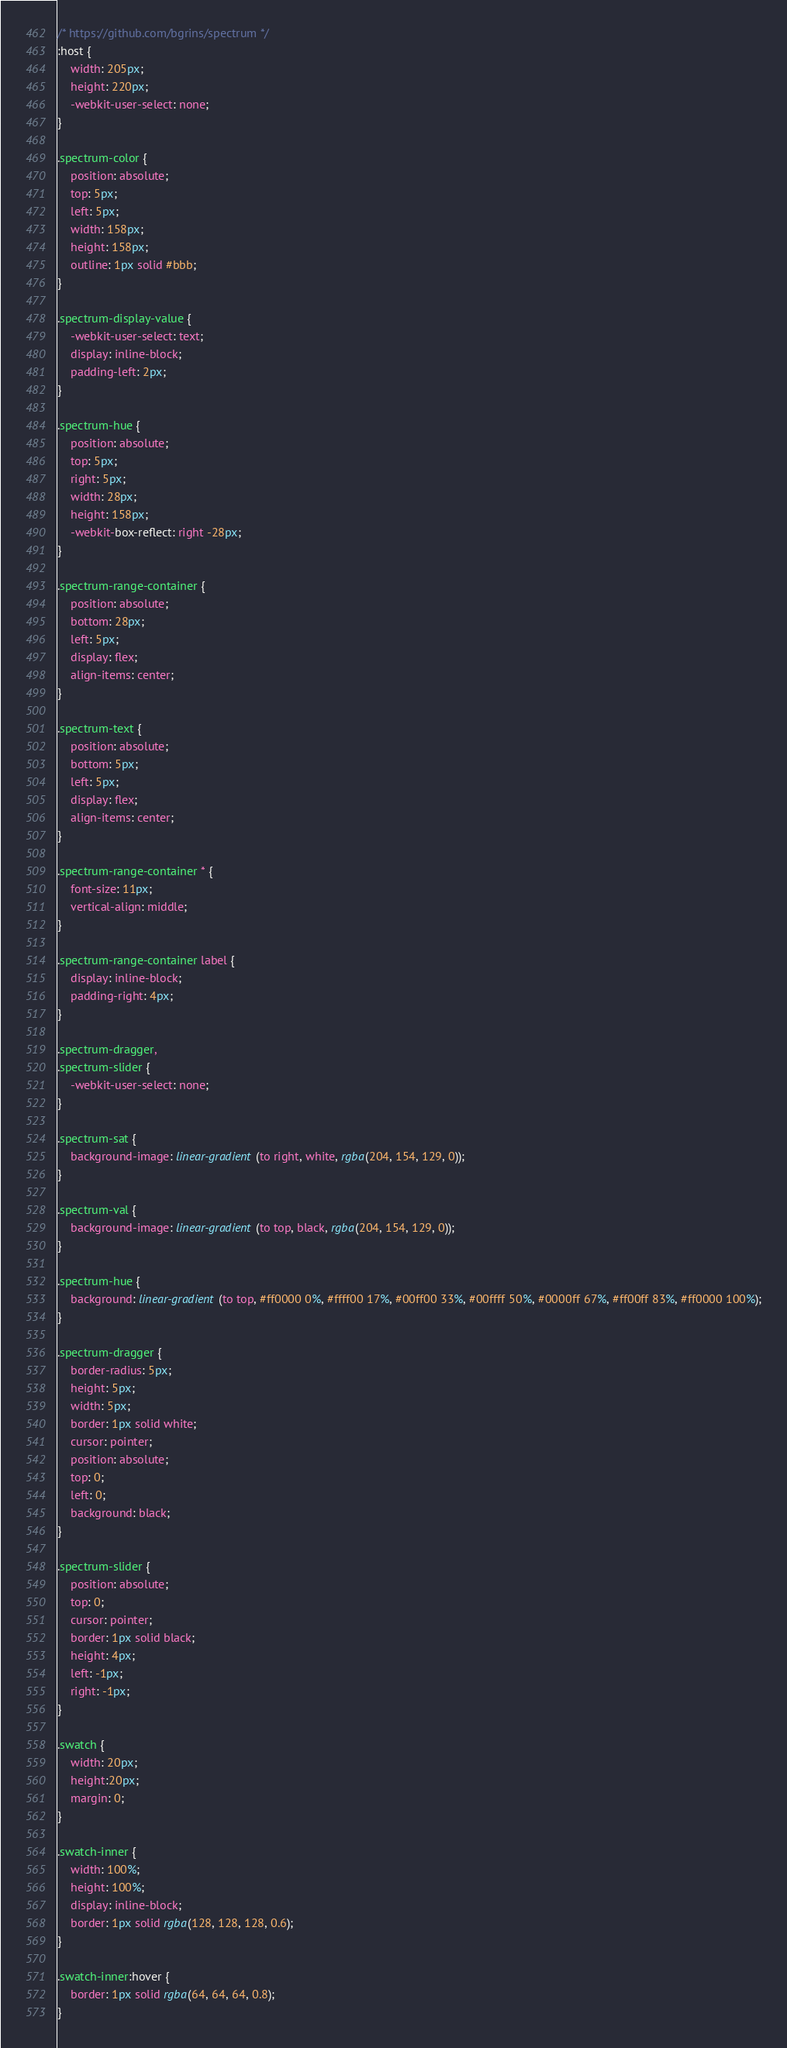<code> <loc_0><loc_0><loc_500><loc_500><_CSS_>/* https://github.com/bgrins/spectrum */
:host {
    width: 205px;
    height: 220px;
    -webkit-user-select: none;
}

.spectrum-color {
    position: absolute;
    top: 5px;
    left: 5px;
    width: 158px;
    height: 158px;
    outline: 1px solid #bbb;
}

.spectrum-display-value {
    -webkit-user-select: text;
    display: inline-block;
    padding-left: 2px;
}

.spectrum-hue {
    position: absolute;
    top: 5px;
    right: 5px;
    width: 28px;
    height: 158px;
    -webkit-box-reflect: right -28px;
}

.spectrum-range-container {
    position: absolute;
    bottom: 28px;
    left: 5px;
    display: flex;
    align-items: center;
}

.spectrum-text {
    position: absolute;
    bottom: 5px;
    left: 5px;
    display: flex;
    align-items: center;
}

.spectrum-range-container * {
    font-size: 11px;
    vertical-align: middle;
}

.spectrum-range-container label {
    display: inline-block;
    padding-right: 4px;
}

.spectrum-dragger,
.spectrum-slider {
    -webkit-user-select: none;
}

.spectrum-sat {
    background-image: linear-gradient(to right, white, rgba(204, 154, 129, 0));
}

.spectrum-val {
    background-image: linear-gradient(to top, black, rgba(204, 154, 129, 0));
}

.spectrum-hue {
    background: linear-gradient(to top, #ff0000 0%, #ffff00 17%, #00ff00 33%, #00ffff 50%, #0000ff 67%, #ff00ff 83%, #ff0000 100%);
}

.spectrum-dragger {
    border-radius: 5px;
    height: 5px;
    width: 5px;
    border: 1px solid white;
    cursor: pointer;
    position: absolute;
    top: 0;
    left: 0;
    background: black;
}

.spectrum-slider {
    position: absolute;
    top: 0;
    cursor: pointer;
    border: 1px solid black;
    height: 4px;
    left: -1px;
    right: -1px;
}

.swatch {
    width: 20px;
    height:20px;
    margin: 0;
}

.swatch-inner {
    width: 100%;
    height: 100%;
    display: inline-block;
    border: 1px solid rgba(128, 128, 128, 0.6);
}

.swatch-inner:hover {
    border: 1px solid rgba(64, 64, 64, 0.8);
}
</code> 